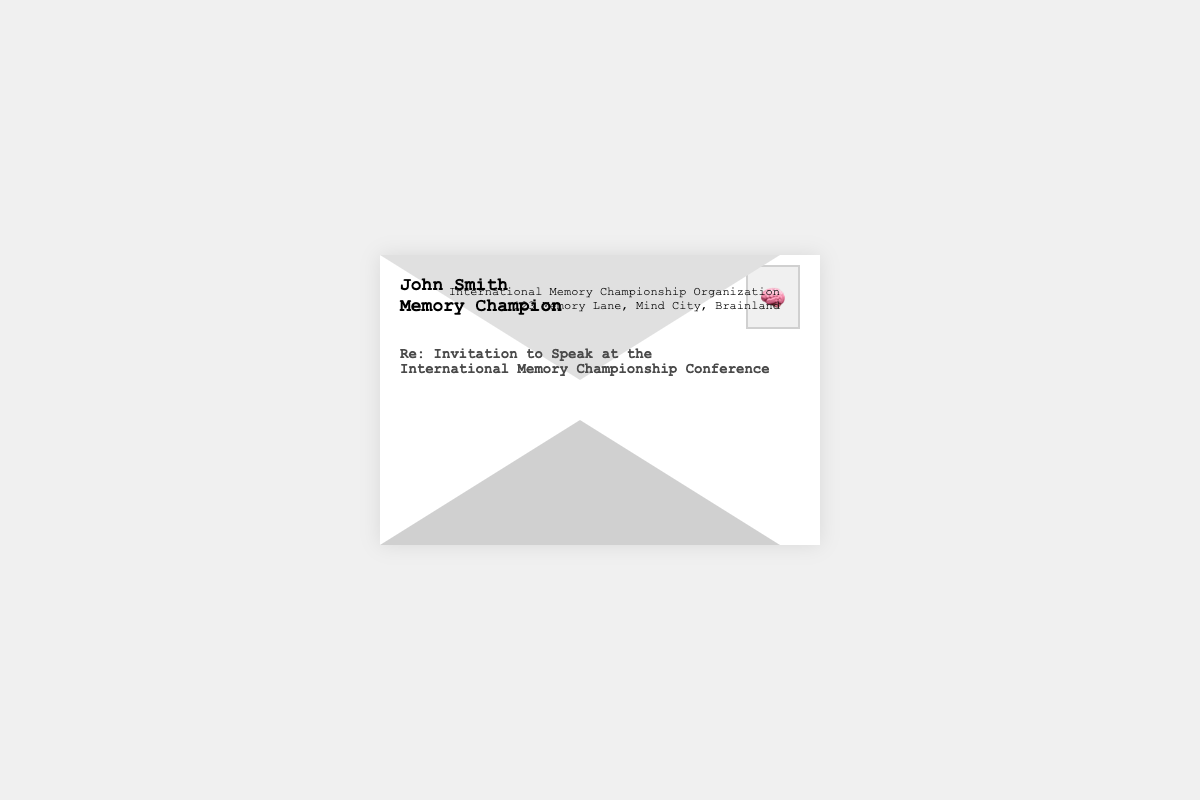What is the name of the invitee? The invitee's name is displayed prominently in the addressee section of the envelope.
Answer: John Smith What is the title of the invitee? The title of the invitee is listed below the name in the addressee section.
Answer: Memory Champion Who sent the invitation? The sender information is located at the top right corner of the envelope.
Answer: International Memory Championship Organization What is the address of the sender? The sender's address is provided in the sender section of the envelope.
Answer: 123 Memory Lane, Mind City, Brainland What type of event is this invitation for? The subject line specifies the purpose of the invitation in the document.
Answer: International Memory Championship Conference What symbol is used as a stamp on the envelope? The stamp section of the envelope contains an image that represents the envelope's context.
Answer: 🧠 How many lines are in the sender's address? Counting the lines in the sender's address provides insight into the detail of the sender's location.
Answer: 2 What is the color of the subject text? The design specifications indicate the styling of the subject text in the envelope.
Answer: #4a4a4a What is the primary font used in the envelope? The font family is mentioned in the CSS styling of the document, indicating the design choices.
Answer: Courier New 